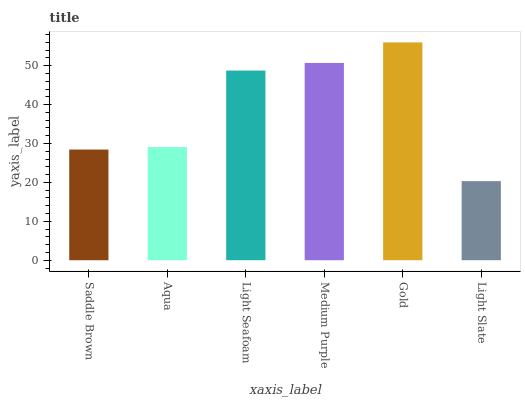Is Light Slate the minimum?
Answer yes or no. Yes. Is Gold the maximum?
Answer yes or no. Yes. Is Aqua the minimum?
Answer yes or no. No. Is Aqua the maximum?
Answer yes or no. No. Is Aqua greater than Saddle Brown?
Answer yes or no. Yes. Is Saddle Brown less than Aqua?
Answer yes or no. Yes. Is Saddle Brown greater than Aqua?
Answer yes or no. No. Is Aqua less than Saddle Brown?
Answer yes or no. No. Is Light Seafoam the high median?
Answer yes or no. Yes. Is Aqua the low median?
Answer yes or no. Yes. Is Gold the high median?
Answer yes or no. No. Is Gold the low median?
Answer yes or no. No. 